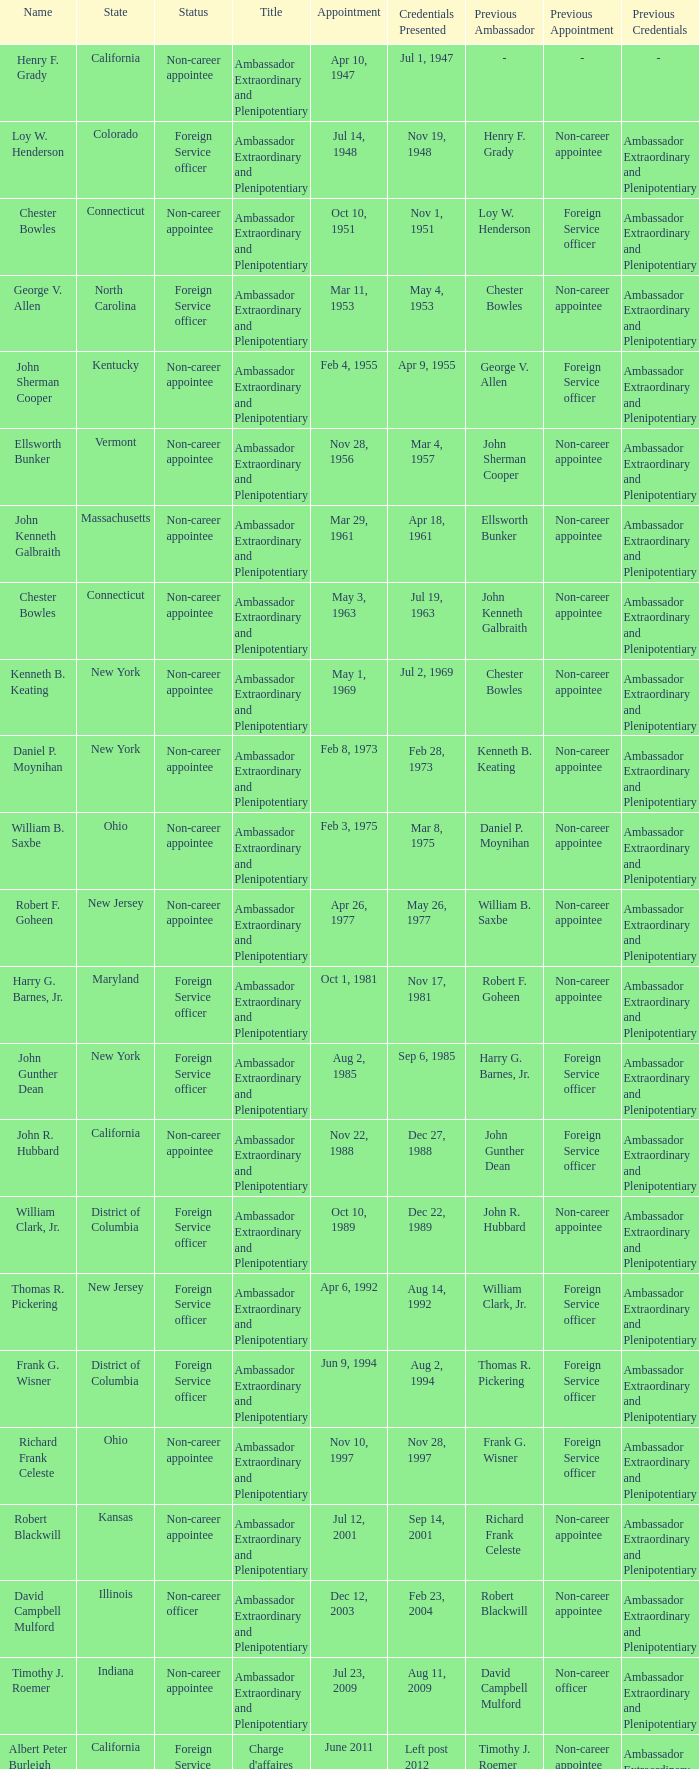Which state has a scheduled appointment on july 12, 2001? Kansas. 